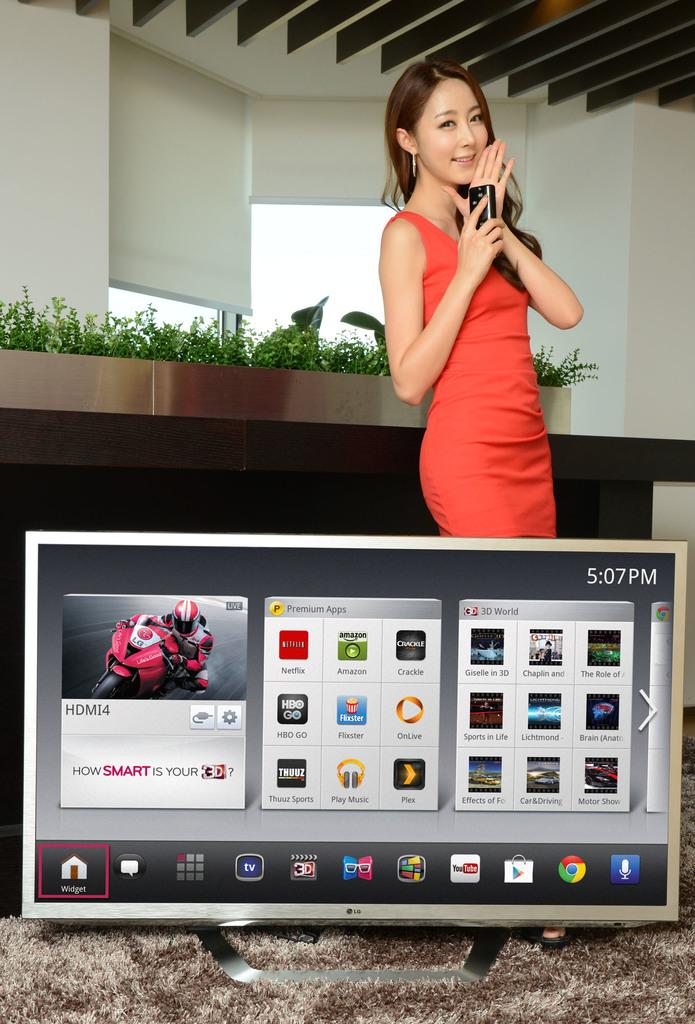What is the main object in the image? There is a screen in the image. Can you describe the person in the image? There is a person wearing an orange dress in the image. What can be seen in the background of the image? There are plants and window blinds in the background of the image. What type of lip can be seen on the person wearing the orange dress in the image? There is no lip visible on the person wearing the orange dress in the image. What kind of pie is being served on the screen in the image? There is no pie visible on the screen in the image. 